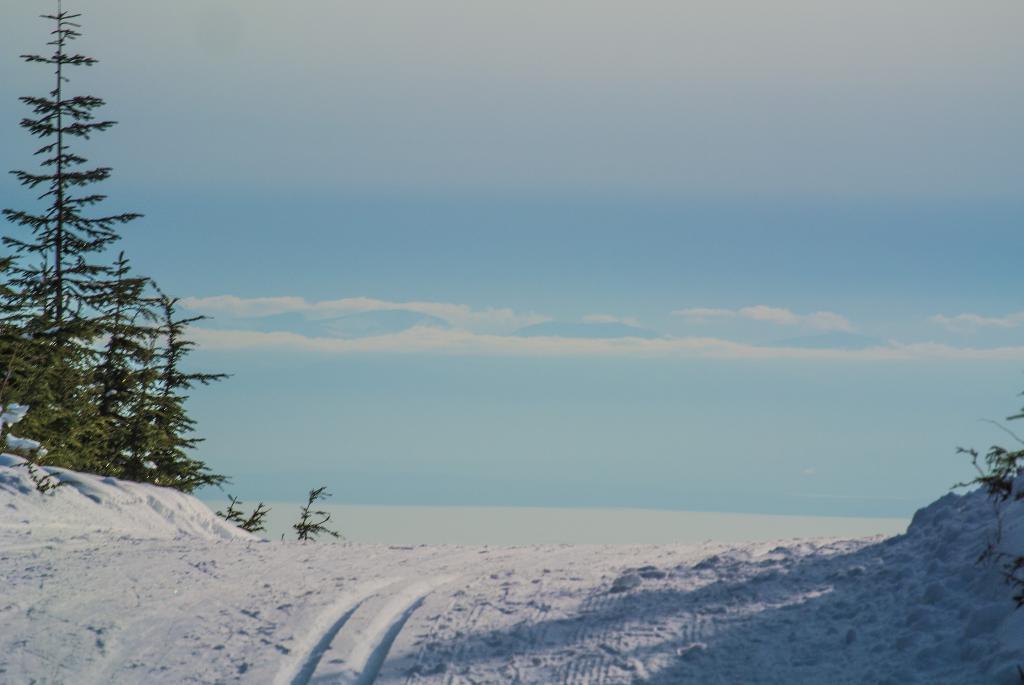Can you describe this image briefly? As we can see in the image there is snow, trees, sky and clouds. 